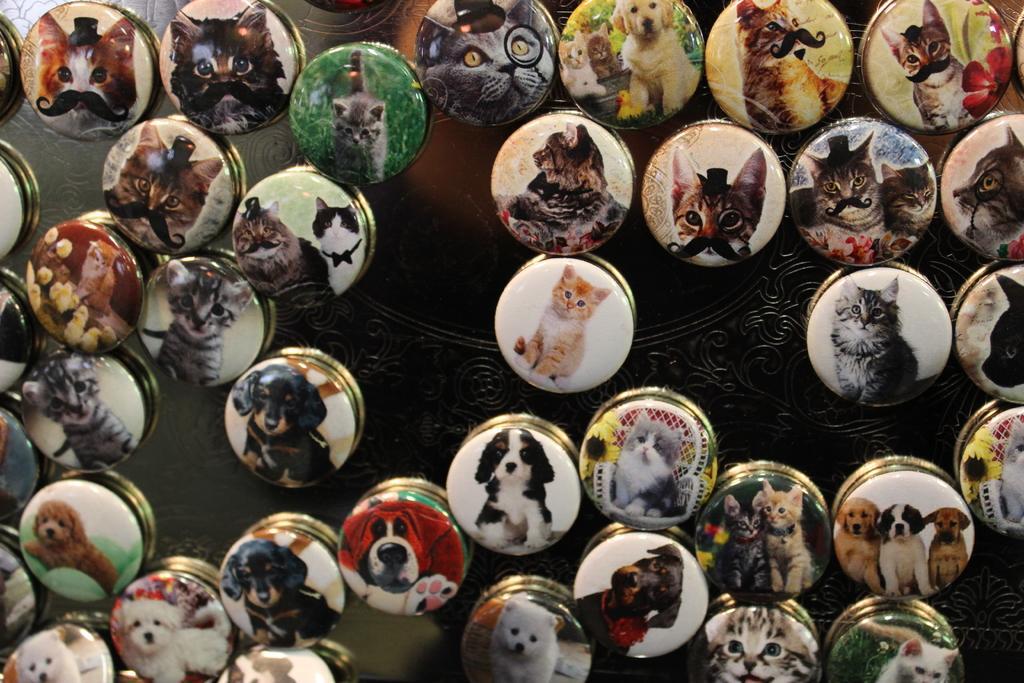Please provide a concise description of this image. In this image, I can see a lot of batches, On each batch, I can see a different kind of animal images. 